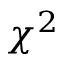<formula> <loc_0><loc_0><loc_500><loc_500>\chi ^ { 2 }</formula> 